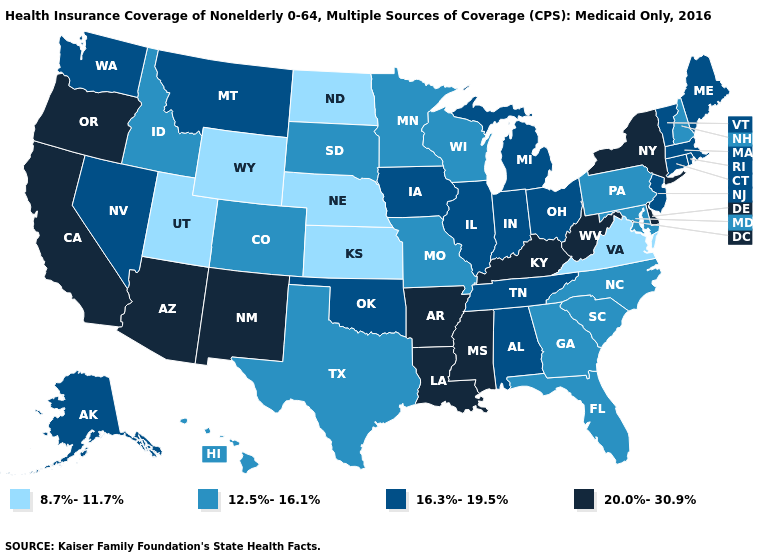What is the lowest value in states that border Nevada?
Concise answer only. 8.7%-11.7%. How many symbols are there in the legend?
Write a very short answer. 4. Name the states that have a value in the range 8.7%-11.7%?
Concise answer only. Kansas, Nebraska, North Dakota, Utah, Virginia, Wyoming. Does Arkansas have the highest value in the USA?
Be succinct. Yes. How many symbols are there in the legend?
Concise answer only. 4. What is the value of Wisconsin?
Quick response, please. 12.5%-16.1%. Does New Jersey have the lowest value in the Northeast?
Answer briefly. No. Name the states that have a value in the range 20.0%-30.9%?
Keep it brief. Arizona, Arkansas, California, Delaware, Kentucky, Louisiana, Mississippi, New Mexico, New York, Oregon, West Virginia. Among the states that border Maryland , which have the highest value?
Write a very short answer. Delaware, West Virginia. Name the states that have a value in the range 16.3%-19.5%?
Answer briefly. Alabama, Alaska, Connecticut, Illinois, Indiana, Iowa, Maine, Massachusetts, Michigan, Montana, Nevada, New Jersey, Ohio, Oklahoma, Rhode Island, Tennessee, Vermont, Washington. What is the lowest value in the USA?
Concise answer only. 8.7%-11.7%. Among the states that border Connecticut , does New York have the lowest value?
Concise answer only. No. What is the lowest value in the Northeast?
Write a very short answer. 12.5%-16.1%. What is the value of Illinois?
Short answer required. 16.3%-19.5%. What is the value of Virginia?
Concise answer only. 8.7%-11.7%. 